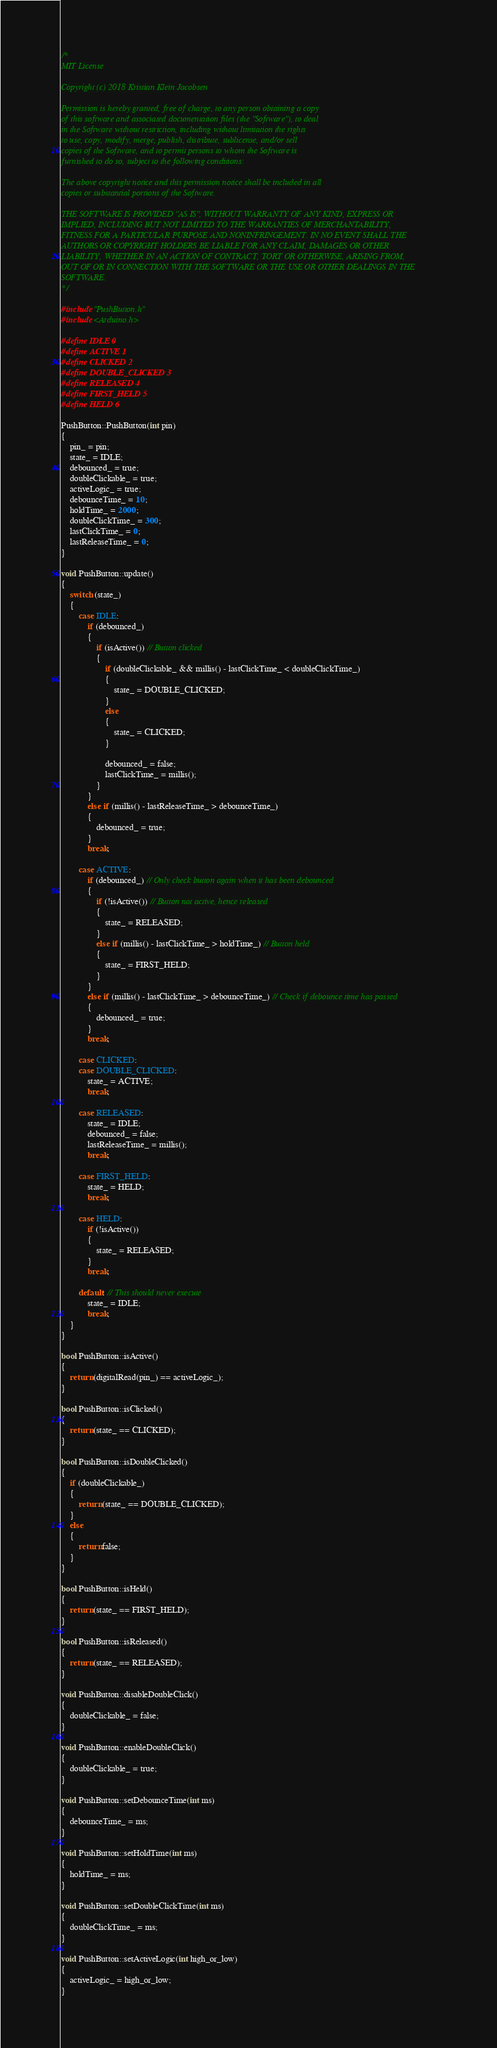Convert code to text. <code><loc_0><loc_0><loc_500><loc_500><_C++_>/*
MIT License

Copyright (c) 2018 Kristian Klein Jacobsen

Permission is hereby granted, free of charge, to any person obtaining a copy
of this software and associated documentation files (the "Software"), to deal
in the Software without restriction, including without limitation the rights
to use, copy, modify, merge, publish, distribute, sublicense, and/or sell
copies of the Software, and to permit persons to whom the Software is
furnished to do so, subject to the following conditions:

The above copyright notice and this permission notice shall be included in all
copies or substantial portions of the Software.

THE SOFTWARE IS PROVIDED "AS IS", WITHOUT WARRANTY OF ANY KIND, EXPRESS OR
IMPLIED, INCLUDING BUT NOT LIMITED TO THE WARRANTIES OF MERCHANTABILITY,
FITNESS FOR A PARTICULAR PURPOSE AND NONINFRINGEMENT. IN NO EVENT SHALL THE
AUTHORS OR COPYRIGHT HOLDERS BE LIABLE FOR ANY CLAIM, DAMAGES OR OTHER
LIABILITY, WHETHER IN AN ACTION OF CONTRACT, TORT OR OTHERWISE, ARISING FROM,
OUT OF OR IN CONNECTION WITH THE SOFTWARE OR THE USE OR OTHER DEALINGS IN THE
SOFTWARE.
*/

#include "PushButton.h"
#include <Arduino.h>

#define IDLE 0
#define ACTIVE 1
#define CLICKED 2
#define DOUBLE_CLICKED 3
#define RELEASED 4
#define FIRST_HELD 5
#define HELD 6

PushButton::PushButton(int pin)
{
	pin_ = pin;
	state_ = IDLE;
	debounced_ = true;
	doubleClickable_ = true;
	activeLogic_ = true;
	debounceTime_ = 10;
	holdTime_ = 2000;
	doubleClickTime_ = 300;
	lastClickTime_ = 0;
	lastReleaseTime_ = 0;
}

void PushButton::update()
{
	switch (state_)
	{
		case IDLE:
			if (debounced_)
			{
				if (isActive()) // Button clicked
				{	
					if (doubleClickable_ && millis() - lastClickTime_ < doubleClickTime_)
					{
						state_ = DOUBLE_CLICKED;
					}
					else
					{
						state_ = CLICKED;
					}
					
					debounced_ = false;
					lastClickTime_ = millis();
				}
			}
			else if (millis() - lastReleaseTime_ > debounceTime_)
			{
				debounced_ = true;
			}
			break;
			
		case ACTIVE:
			if (debounced_) // Only check button again when it has been debounced
			{
				if (!isActive()) // Button not active, hence released
				{
					state_ = RELEASED;
				}
				else if (millis() - lastClickTime_ > holdTime_) // Button held
				{
					state_ = FIRST_HELD;
				}
			}
			else if (millis() - lastClickTime_ > debounceTime_) // Check if debounce time has passed
			{
				debounced_ = true;
			}
			break;
			
		case CLICKED:
		case DOUBLE_CLICKED:
			state_ = ACTIVE;
			break;
			
		case RELEASED:
			state_ = IDLE;
			debounced_ = false;
			lastReleaseTime_ = millis();
			break;
			
		case FIRST_HELD:
			state_ = HELD;
			break;
		
		case HELD:
			if (!isActive())
			{
				state_ = RELEASED;
			}
			break;
			
		default: // This should never execute
			state_ = IDLE;
			break;
	}
}

bool PushButton::isActive()
{
	return (digitalRead(pin_) == activeLogic_);
}

bool PushButton::isClicked()
{
	return (state_ == CLICKED);
}

bool PushButton::isDoubleClicked()
{
	if (doubleClickable_)
	{
		return (state_ == DOUBLE_CLICKED);
	}
	else
	{
		return false;
	}
}

bool PushButton::isHeld()
{
	return (state_ == FIRST_HELD);
}

bool PushButton::isReleased()
{
	return (state_ == RELEASED);
}

void PushButton::disableDoubleClick()
{
	doubleClickable_ = false;
}

void PushButton::enableDoubleClick()
{
	doubleClickable_ = true;
}

void PushButton::setDebounceTime(int ms)
{
	debounceTime_ = ms;
}

void PushButton::setHoldTime(int ms)
{
	holdTime_ = ms;
}

void PushButton::setDoubleClickTime(int ms)
{
	doubleClickTime_ = ms;
}

void PushButton::setActiveLogic(int high_or_low)
{
	activeLogic_ = high_or_low;
}</code> 